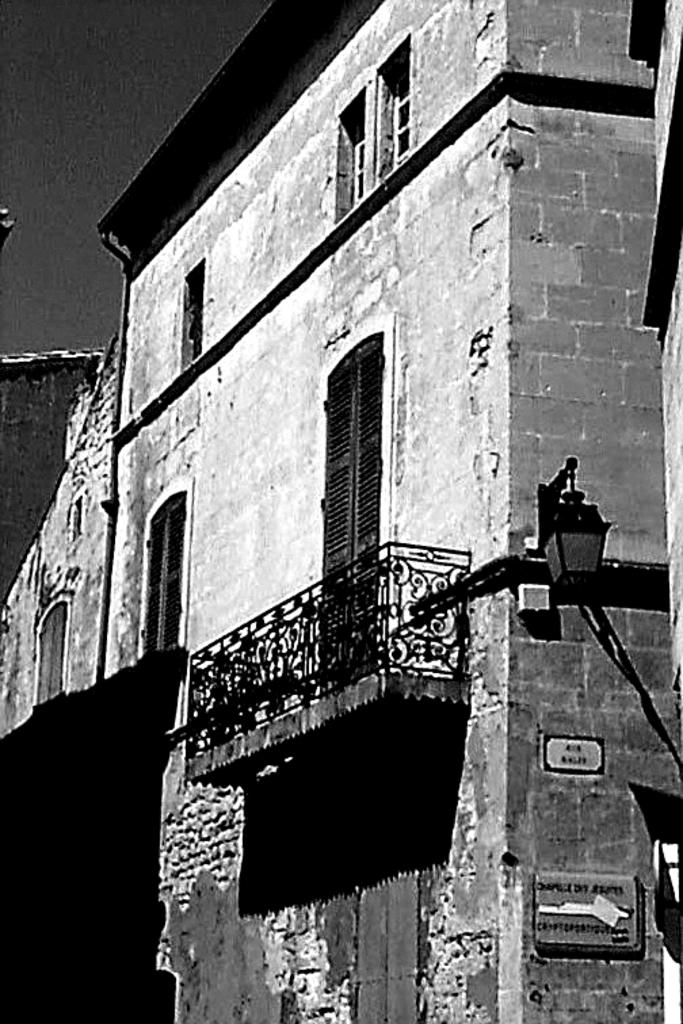What is the main structure in the center of the image? There is a house in the center of the image. What can be seen on the wall at the bottom of the image? There are two boards on the wall at the bottom of the image. What is the source of illumination in the image? There is a light in the image. What is visible at the top of the image? The sky is visible at the top of the image. How many zebras are present in the image? There are no zebras present in the image. What is the wish of the person in the image? There is no person present in the image, so it is impossible to determine their wish. 